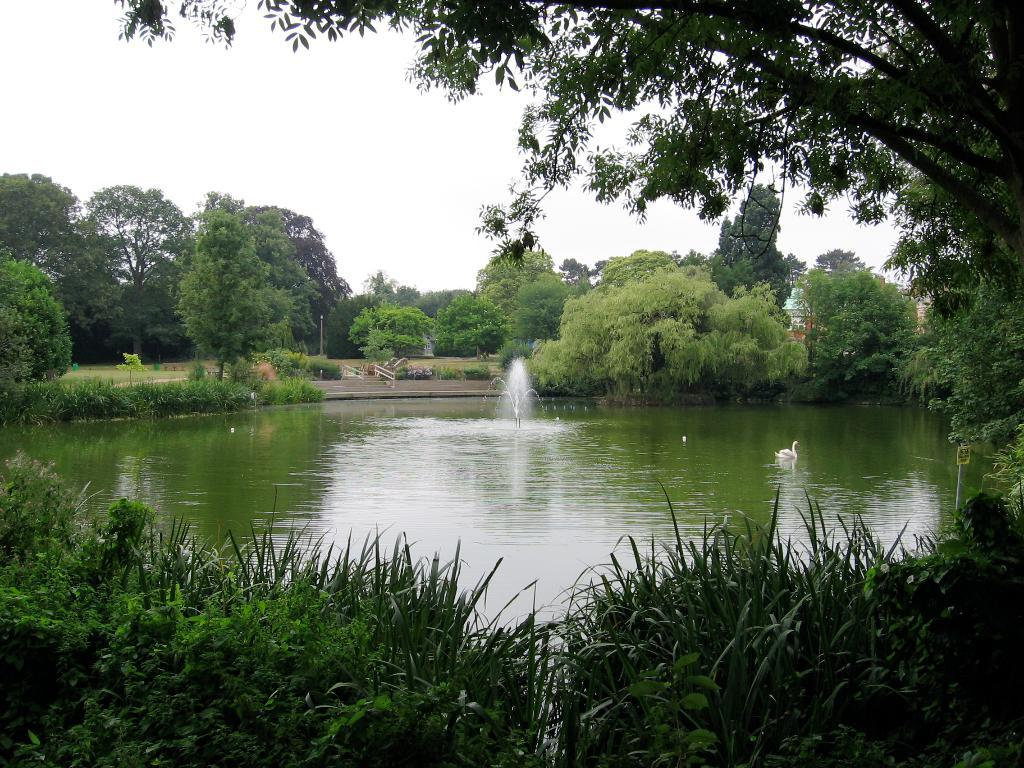What is the main subject in the middle of the image? There is a fountain in the middle of the image. What can be seen in the background of the image? There are trees in the background of the image. What is visible at the top of the image? The sky is visible at the top of the image. What type of news can be heard coming from the church in the image? There is no church or news present in the image; it features a fountain and trees in the background. What kind of cheese is visible on the fountain in the image? There is no cheese present on the fountain or in the image. 